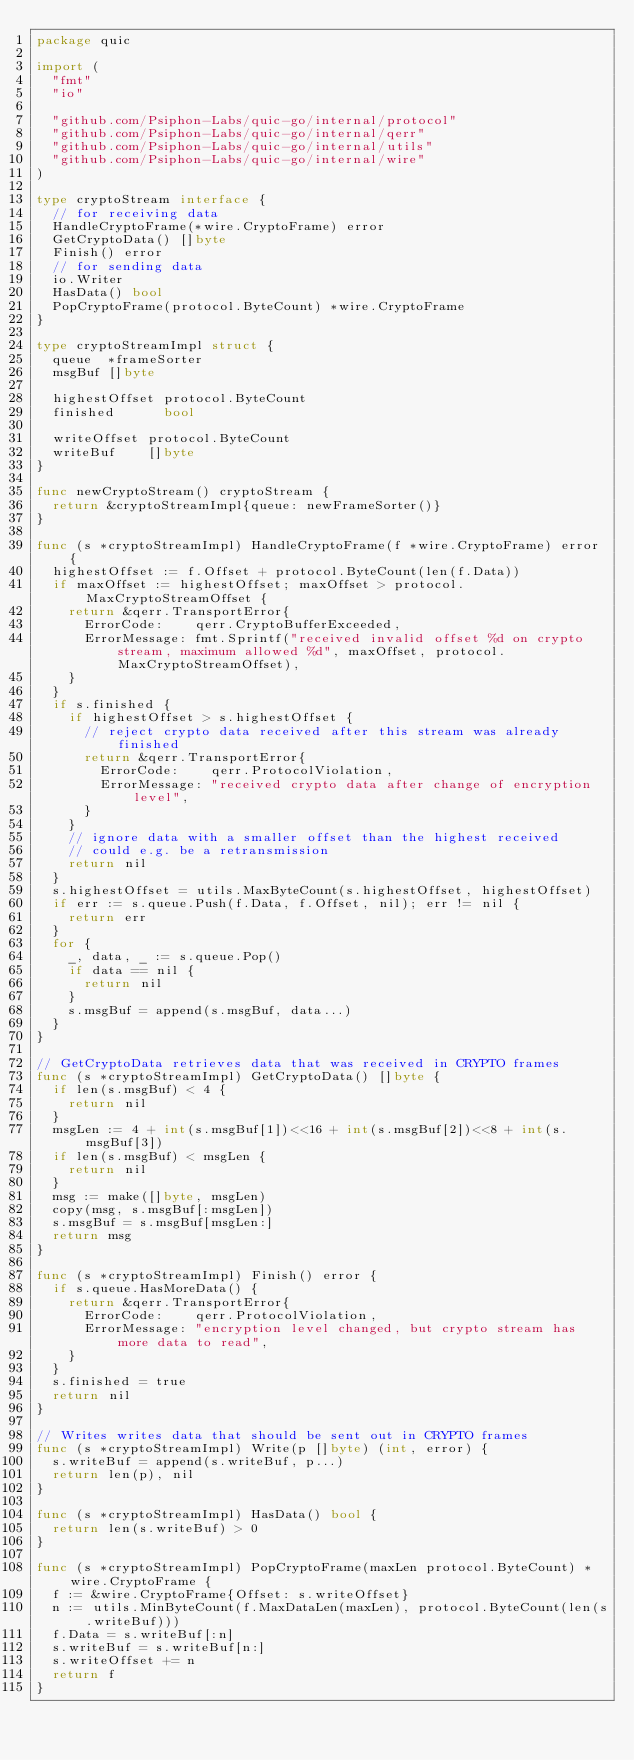<code> <loc_0><loc_0><loc_500><loc_500><_Go_>package quic

import (
	"fmt"
	"io"

	"github.com/Psiphon-Labs/quic-go/internal/protocol"
	"github.com/Psiphon-Labs/quic-go/internal/qerr"
	"github.com/Psiphon-Labs/quic-go/internal/utils"
	"github.com/Psiphon-Labs/quic-go/internal/wire"
)

type cryptoStream interface {
	// for receiving data
	HandleCryptoFrame(*wire.CryptoFrame) error
	GetCryptoData() []byte
	Finish() error
	// for sending data
	io.Writer
	HasData() bool
	PopCryptoFrame(protocol.ByteCount) *wire.CryptoFrame
}

type cryptoStreamImpl struct {
	queue  *frameSorter
	msgBuf []byte

	highestOffset protocol.ByteCount
	finished      bool

	writeOffset protocol.ByteCount
	writeBuf    []byte
}

func newCryptoStream() cryptoStream {
	return &cryptoStreamImpl{queue: newFrameSorter()}
}

func (s *cryptoStreamImpl) HandleCryptoFrame(f *wire.CryptoFrame) error {
	highestOffset := f.Offset + protocol.ByteCount(len(f.Data))
	if maxOffset := highestOffset; maxOffset > protocol.MaxCryptoStreamOffset {
		return &qerr.TransportError{
			ErrorCode:    qerr.CryptoBufferExceeded,
			ErrorMessage: fmt.Sprintf("received invalid offset %d on crypto stream, maximum allowed %d", maxOffset, protocol.MaxCryptoStreamOffset),
		}
	}
	if s.finished {
		if highestOffset > s.highestOffset {
			// reject crypto data received after this stream was already finished
			return &qerr.TransportError{
				ErrorCode:    qerr.ProtocolViolation,
				ErrorMessage: "received crypto data after change of encryption level",
			}
		}
		// ignore data with a smaller offset than the highest received
		// could e.g. be a retransmission
		return nil
	}
	s.highestOffset = utils.MaxByteCount(s.highestOffset, highestOffset)
	if err := s.queue.Push(f.Data, f.Offset, nil); err != nil {
		return err
	}
	for {
		_, data, _ := s.queue.Pop()
		if data == nil {
			return nil
		}
		s.msgBuf = append(s.msgBuf, data...)
	}
}

// GetCryptoData retrieves data that was received in CRYPTO frames
func (s *cryptoStreamImpl) GetCryptoData() []byte {
	if len(s.msgBuf) < 4 {
		return nil
	}
	msgLen := 4 + int(s.msgBuf[1])<<16 + int(s.msgBuf[2])<<8 + int(s.msgBuf[3])
	if len(s.msgBuf) < msgLen {
		return nil
	}
	msg := make([]byte, msgLen)
	copy(msg, s.msgBuf[:msgLen])
	s.msgBuf = s.msgBuf[msgLen:]
	return msg
}

func (s *cryptoStreamImpl) Finish() error {
	if s.queue.HasMoreData() {
		return &qerr.TransportError{
			ErrorCode:    qerr.ProtocolViolation,
			ErrorMessage: "encryption level changed, but crypto stream has more data to read",
		}
	}
	s.finished = true
	return nil
}

// Writes writes data that should be sent out in CRYPTO frames
func (s *cryptoStreamImpl) Write(p []byte) (int, error) {
	s.writeBuf = append(s.writeBuf, p...)
	return len(p), nil
}

func (s *cryptoStreamImpl) HasData() bool {
	return len(s.writeBuf) > 0
}

func (s *cryptoStreamImpl) PopCryptoFrame(maxLen protocol.ByteCount) *wire.CryptoFrame {
	f := &wire.CryptoFrame{Offset: s.writeOffset}
	n := utils.MinByteCount(f.MaxDataLen(maxLen), protocol.ByteCount(len(s.writeBuf)))
	f.Data = s.writeBuf[:n]
	s.writeBuf = s.writeBuf[n:]
	s.writeOffset += n
	return f
}
</code> 